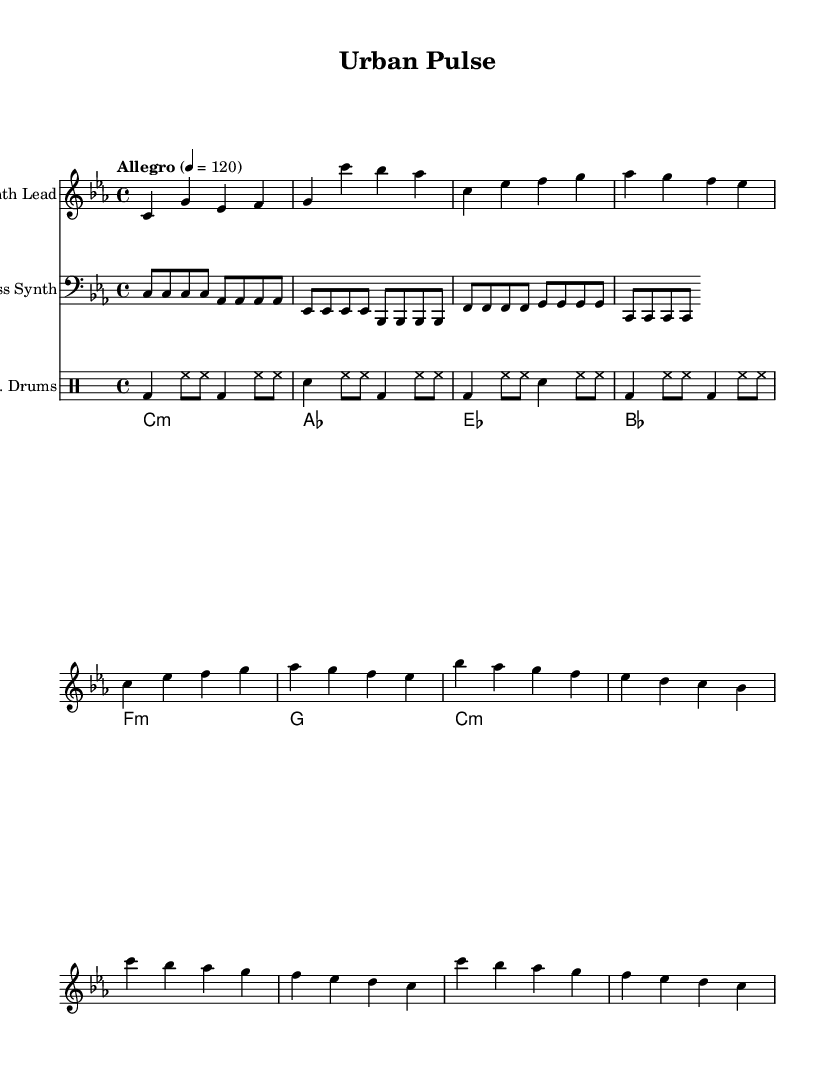What is the key signature of this music? The key signature is C minor, indicated by three flat symbols on the staff.
Answer: C minor What is the time signature of the piece? The time signature is shown as 4/4, meaning there are four beats in each measure with a quarter note getting one beat.
Answer: 4/4 What is the tempo marking for this composition? The tempo marking states "Allegro" with a metronome marking of 120 beats per minute, which is a standard tempo indication.
Answer: Allegro, 120 Which section of the music starts with "c4 g' es f"? This sequence corresponds to the Intro of the piece, as it is located at the beginning of the composition.
Answer: Intro How many beats are in the chorus? The chorus can be analyzed by counting the measures which amount to 8 beats based on the 4/4 time signature, as there are two measures of 4 beats each in the chorus section.
Answer: 8 What kind of rhythmic pattern is displayed in the drums part? The drums part shows a basic four-on-the-floor pattern characterized by the bass drum hit on each quarter note, combined with hi-hats and snare accents, typical of electronic dance music.
Answer: Four-on-the-floor What is the root of the first chord in the piece? The first chord is identified as C minor based on the chord notation, represented as "c1:m" in the chords section.
Answer: C minor 